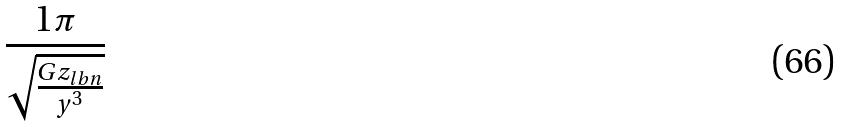<formula> <loc_0><loc_0><loc_500><loc_500>\frac { 1 \pi } { \sqrt { \frac { G z _ { l b n } } { y ^ { 3 } } } }</formula> 